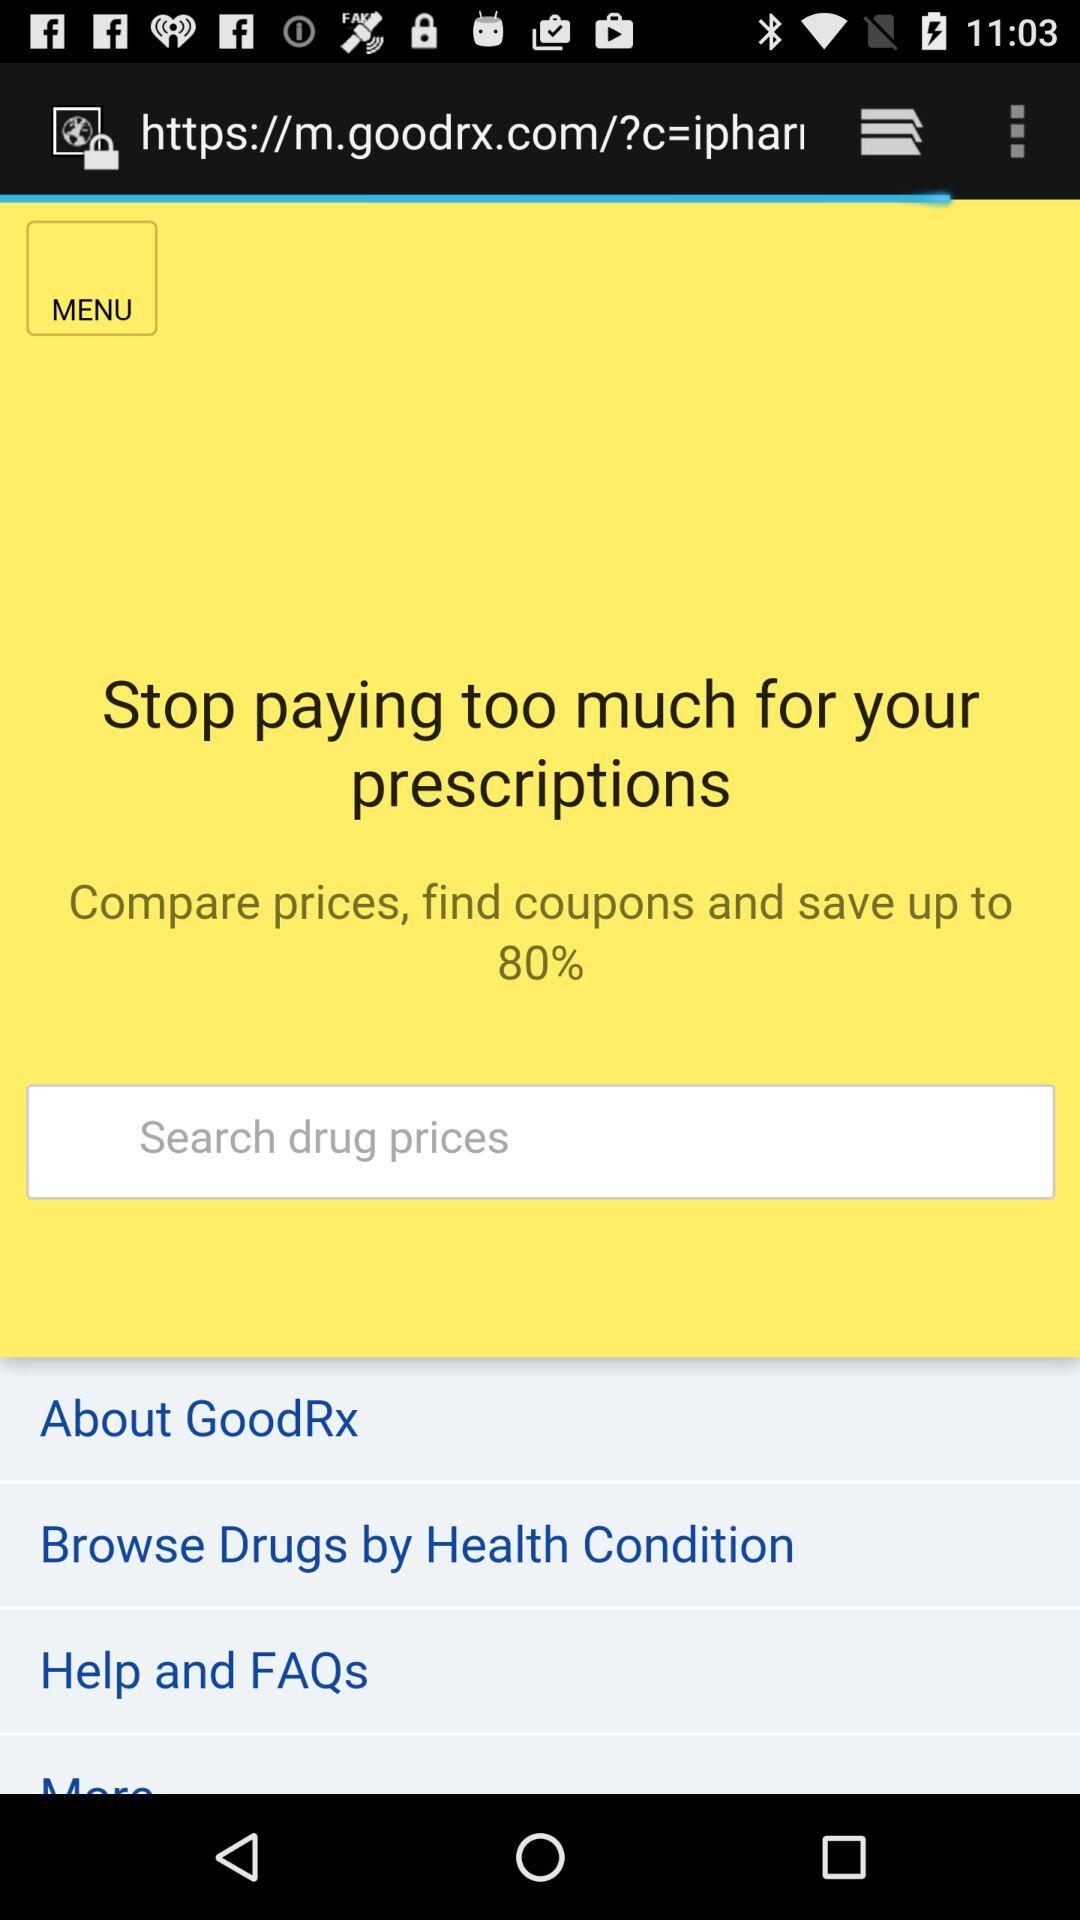How much of a percentage can we save on prescriptions? You can save up to 80%. 